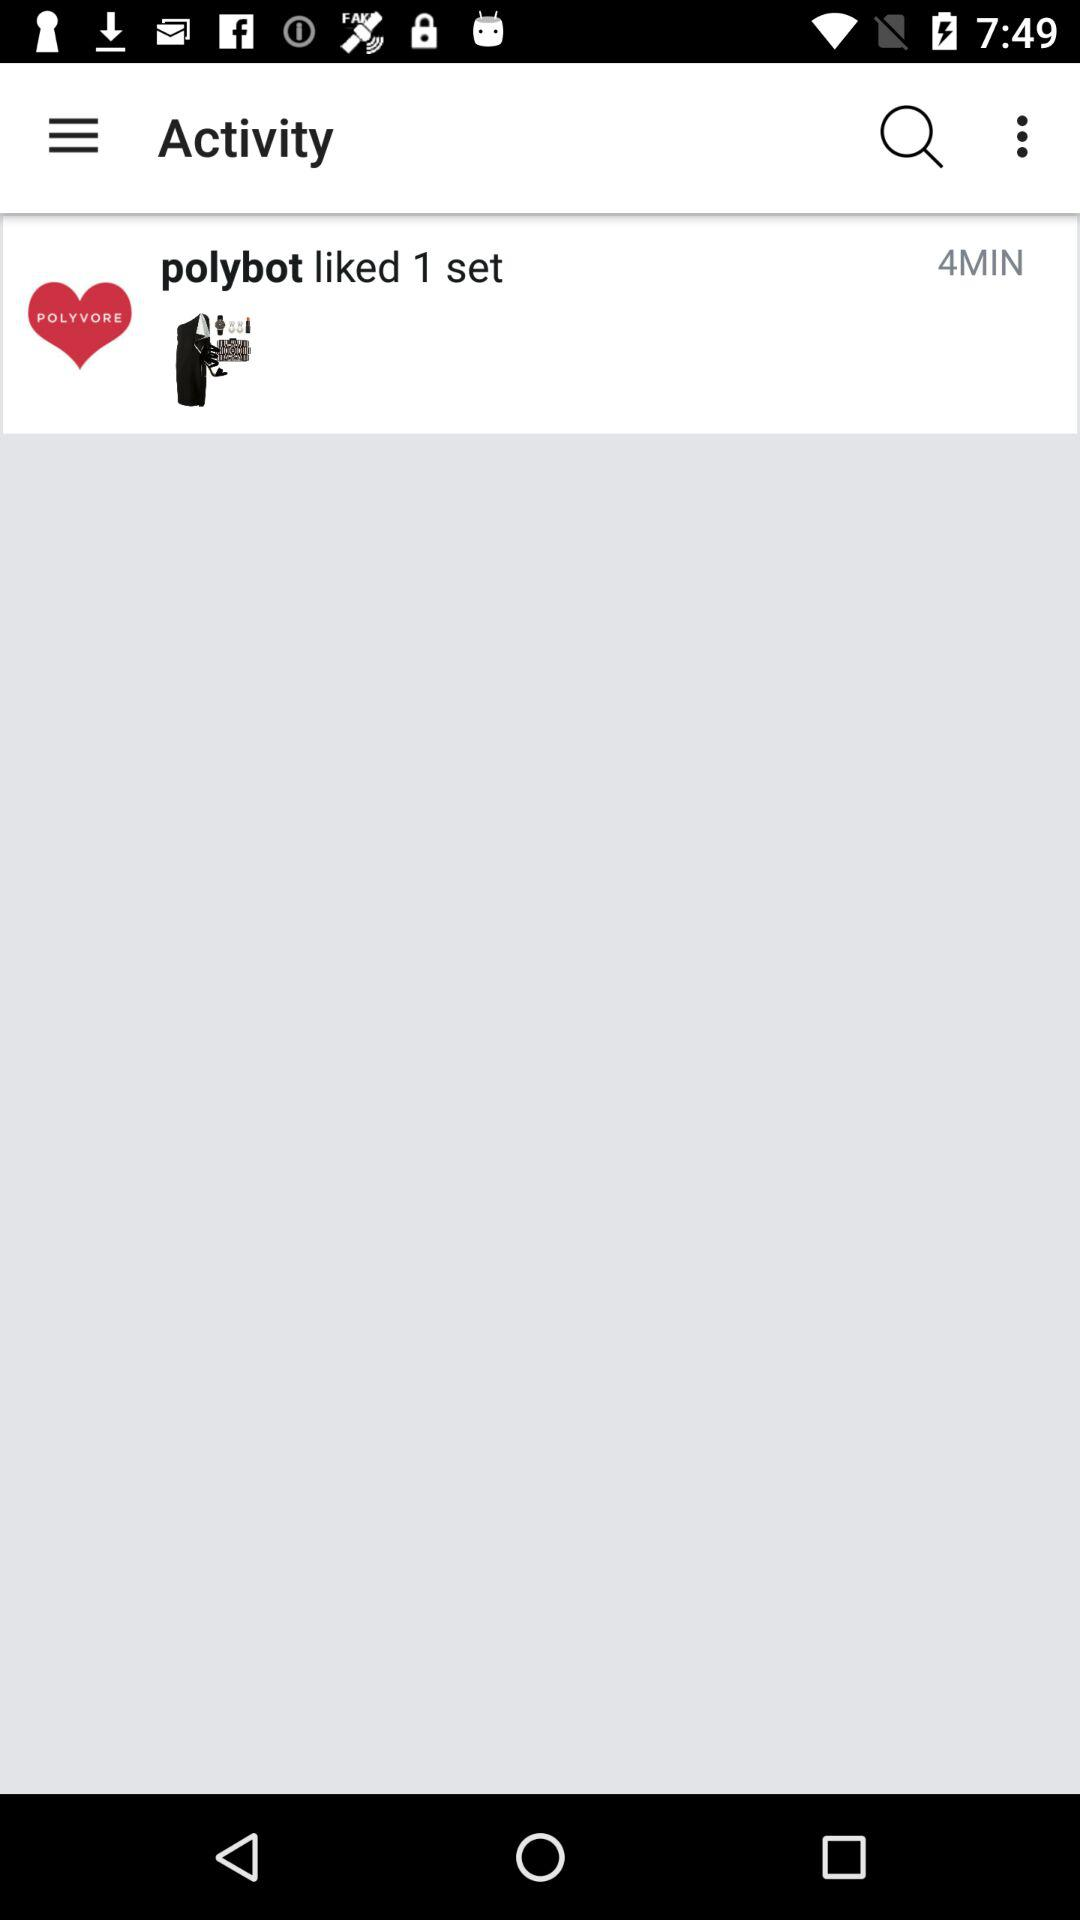How many minutes ago was the last activity?
Answer the question using a single word or phrase. 4 